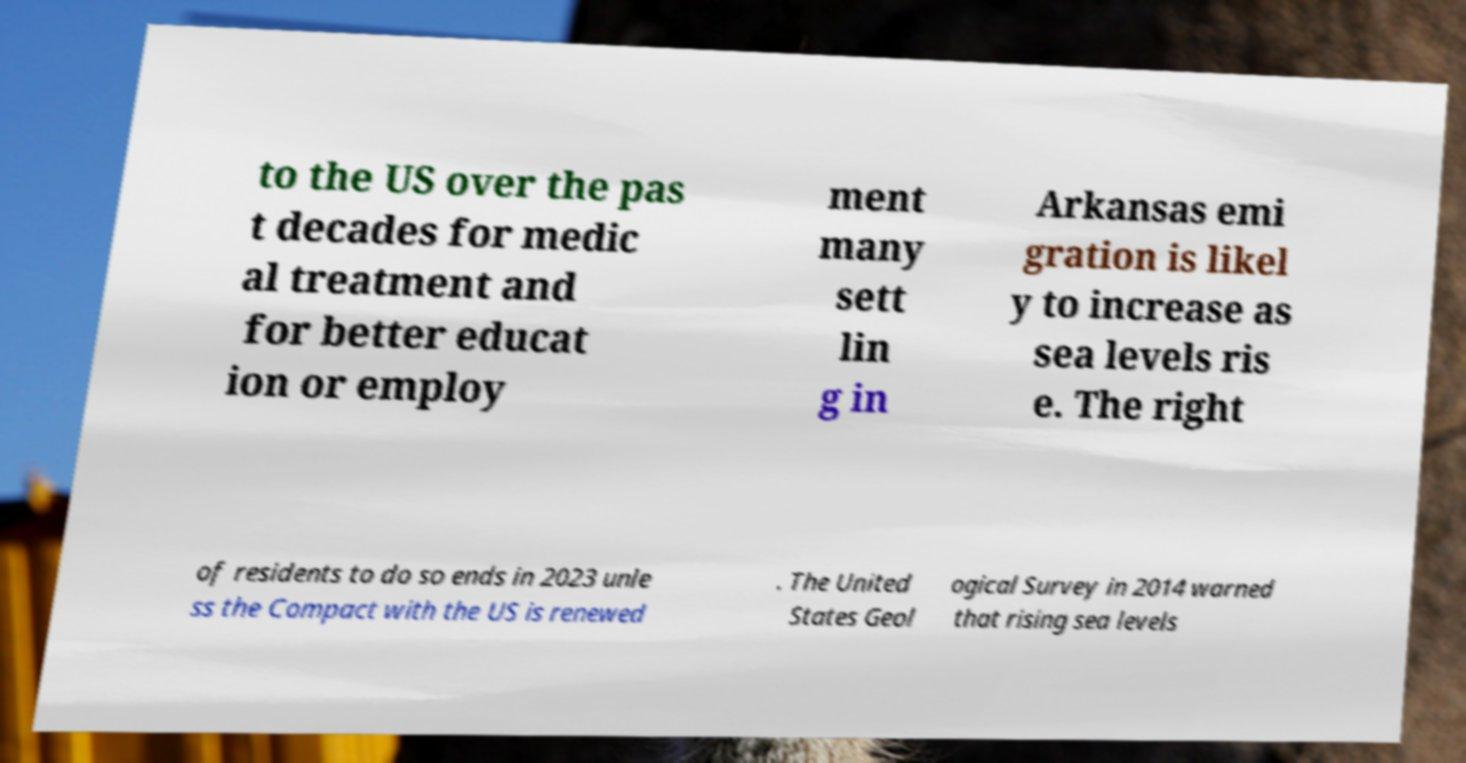There's text embedded in this image that I need extracted. Can you transcribe it verbatim? to the US over the pas t decades for medic al treatment and for better educat ion or employ ment many sett lin g in Arkansas emi gration is likel y to increase as sea levels ris e. The right of residents to do so ends in 2023 unle ss the Compact with the US is renewed . The United States Geol ogical Survey in 2014 warned that rising sea levels 